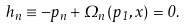Convert formula to latex. <formula><loc_0><loc_0><loc_500><loc_500>h _ { n } \equiv - p _ { n } + \Omega _ { n } \left ( p _ { 1 } , x \right ) = 0 .</formula> 